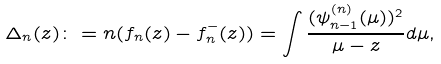Convert formula to latex. <formula><loc_0><loc_0><loc_500><loc_500>\Delta _ { n } ( z ) \colon = n ( f _ { n } ( z ) - f _ { n } ^ { - } ( z ) ) = \int \frac { ( \psi _ { n - 1 } ^ { ( n ) } ( \mu ) ) ^ { 2 } } { \mu - z } d \mu ,</formula> 